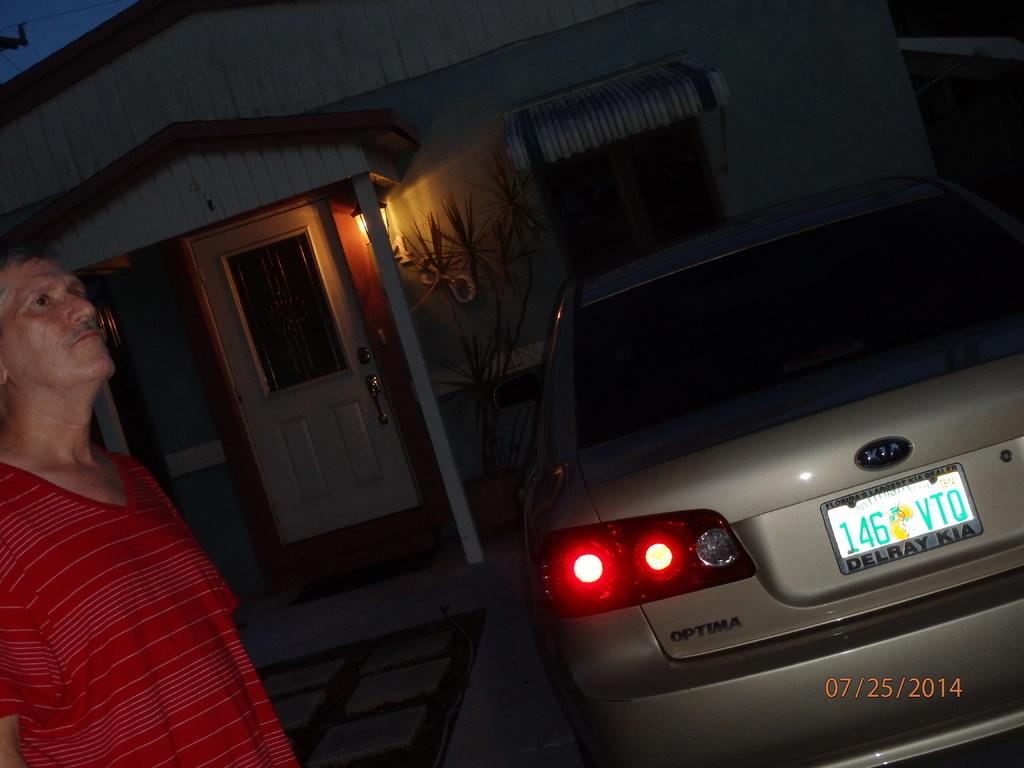<image>
Summarize the visual content of the image. A car made by KIA has a license plate that reads "146VTO." 